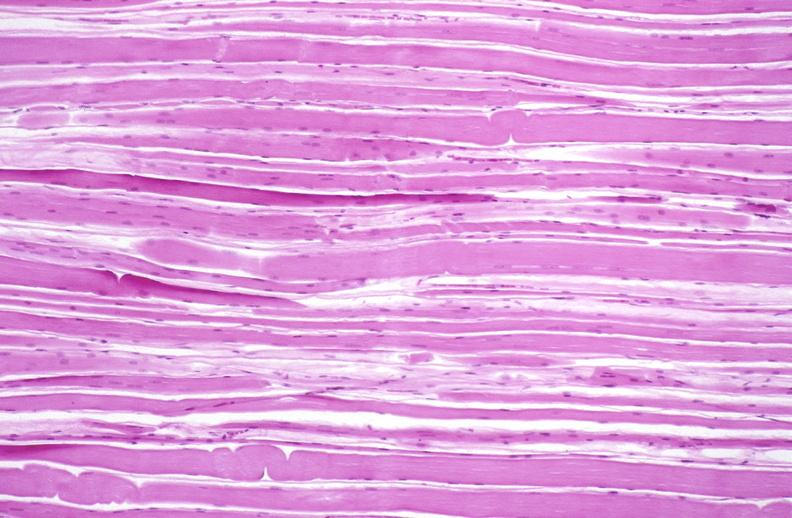s sugar coated present?
Answer the question using a single word or phrase. No 